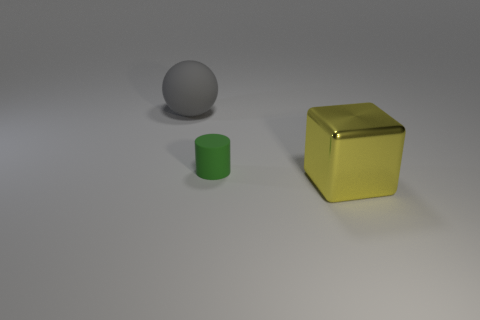Subtract all cubes. How many objects are left? 2 Add 2 red matte balls. How many objects exist? 5 Subtract 1 cylinders. How many cylinders are left? 0 Add 3 small green cylinders. How many small green cylinders are left? 4 Add 3 red matte spheres. How many red matte spheres exist? 3 Subtract 0 blue cylinders. How many objects are left? 3 Subtract all cyan spheres. Subtract all red blocks. How many spheres are left? 1 Subtract all red balls. How many brown cylinders are left? 0 Subtract all big blue metallic cylinders. Subtract all rubber things. How many objects are left? 1 